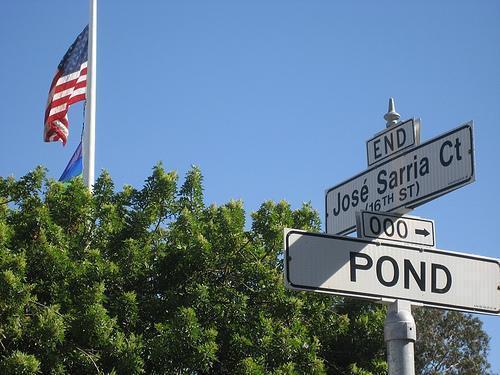How many street signs do you see?
Give a very brief answer. 2. 